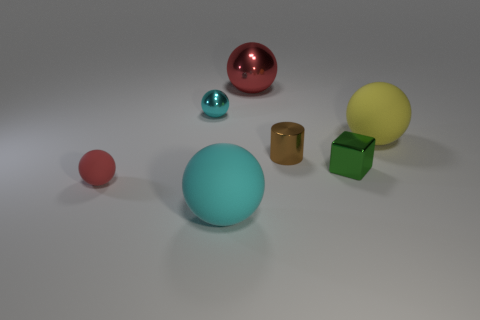Subtract all big yellow rubber balls. How many balls are left? 4 Subtract all red balls. How many balls are left? 3 Add 1 small brown metal cylinders. How many objects exist? 8 Subtract all cubes. How many objects are left? 6 Subtract 3 balls. How many balls are left? 2 Add 5 brown cylinders. How many brown cylinders exist? 6 Subtract 0 purple balls. How many objects are left? 7 Subtract all green spheres. Subtract all blue cylinders. How many spheres are left? 5 Subtract all yellow balls. How many red cubes are left? 0 Subtract all tiny green shiny cubes. Subtract all cyan objects. How many objects are left? 4 